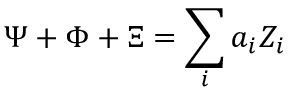Convert formula to latex. <formula><loc_0><loc_0><loc_500><loc_500>\Psi + \Phi + \Xi = \sum _ { i } a _ { i } Z _ { i }</formula> 